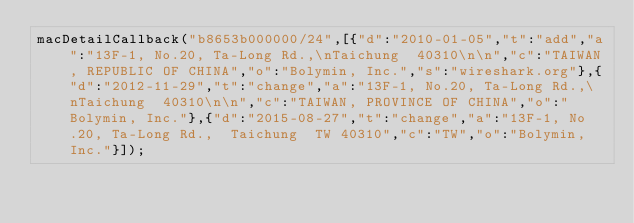Convert code to text. <code><loc_0><loc_0><loc_500><loc_500><_JavaScript_>macDetailCallback("b8653b000000/24",[{"d":"2010-01-05","t":"add","a":"13F-1, No.20, Ta-Long Rd.,\nTaichung  40310\n\n","c":"TAIWAN, REPUBLIC OF CHINA","o":"Bolymin, Inc.","s":"wireshark.org"},{"d":"2012-11-29","t":"change","a":"13F-1, No.20, Ta-Long Rd.,\nTaichung  40310\n\n","c":"TAIWAN, PROVINCE OF CHINA","o":"Bolymin, Inc."},{"d":"2015-08-27","t":"change","a":"13F-1, No.20, Ta-Long Rd.,  Taichung  TW 40310","c":"TW","o":"Bolymin, Inc."}]);
</code> 